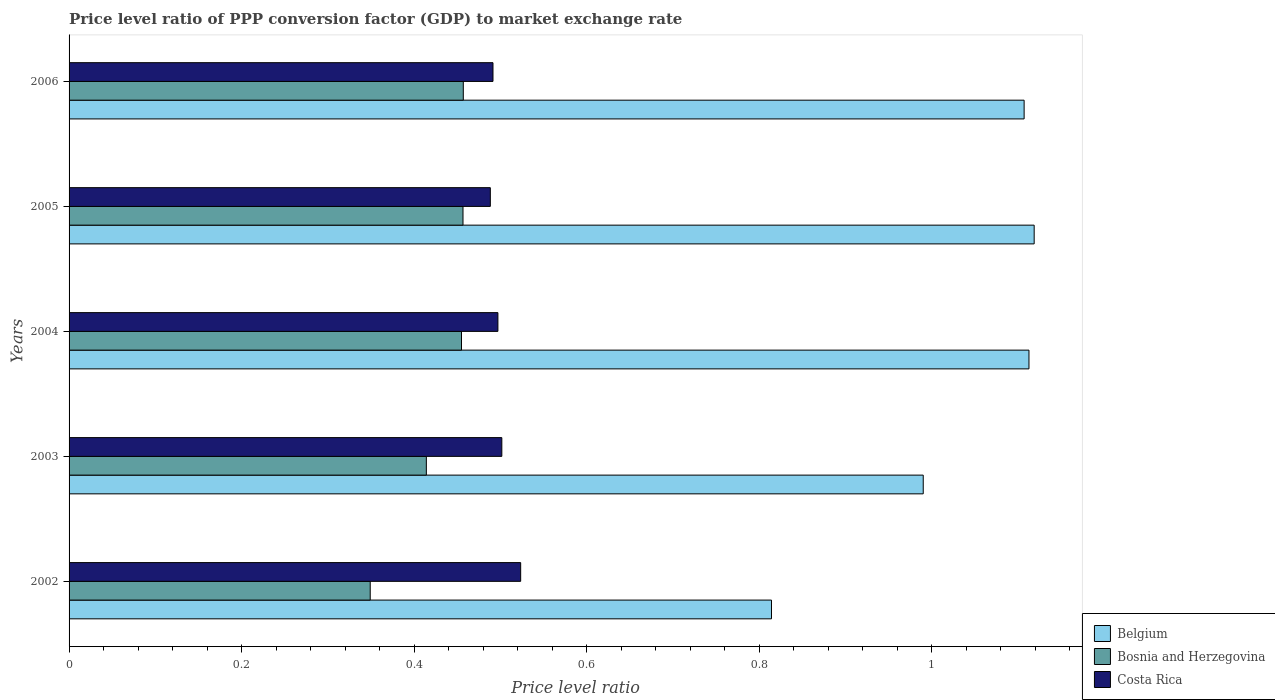How many different coloured bars are there?
Give a very brief answer. 3. Are the number of bars per tick equal to the number of legend labels?
Offer a terse response. Yes. How many bars are there on the 3rd tick from the bottom?
Offer a very short reply. 3. In how many cases, is the number of bars for a given year not equal to the number of legend labels?
Make the answer very short. 0. What is the price level ratio in Costa Rica in 2005?
Give a very brief answer. 0.49. Across all years, what is the maximum price level ratio in Costa Rica?
Keep it short and to the point. 0.52. Across all years, what is the minimum price level ratio in Bosnia and Herzegovina?
Offer a very short reply. 0.35. In which year was the price level ratio in Costa Rica maximum?
Make the answer very short. 2002. What is the total price level ratio in Costa Rica in the graph?
Offer a terse response. 2.5. What is the difference between the price level ratio in Belgium in 2002 and that in 2003?
Your answer should be very brief. -0.18. What is the difference between the price level ratio in Costa Rica in 2006 and the price level ratio in Belgium in 2005?
Your answer should be very brief. -0.63. What is the average price level ratio in Costa Rica per year?
Offer a terse response. 0.5. In the year 2003, what is the difference between the price level ratio in Belgium and price level ratio in Costa Rica?
Offer a terse response. 0.49. In how many years, is the price level ratio in Bosnia and Herzegovina greater than 0.12 ?
Give a very brief answer. 5. What is the ratio of the price level ratio in Bosnia and Herzegovina in 2004 to that in 2006?
Offer a terse response. 1. What is the difference between the highest and the second highest price level ratio in Bosnia and Herzegovina?
Offer a very short reply. 0. What is the difference between the highest and the lowest price level ratio in Bosnia and Herzegovina?
Keep it short and to the point. 0.11. In how many years, is the price level ratio in Bosnia and Herzegovina greater than the average price level ratio in Bosnia and Herzegovina taken over all years?
Make the answer very short. 3. Is the sum of the price level ratio in Bosnia and Herzegovina in 2002 and 2006 greater than the maximum price level ratio in Costa Rica across all years?
Offer a very short reply. Yes. What does the 3rd bar from the bottom in 2002 represents?
Your answer should be very brief. Costa Rica. Is it the case that in every year, the sum of the price level ratio in Costa Rica and price level ratio in Belgium is greater than the price level ratio in Bosnia and Herzegovina?
Provide a short and direct response. Yes. How many bars are there?
Your answer should be very brief. 15. Are all the bars in the graph horizontal?
Make the answer very short. Yes. How many years are there in the graph?
Ensure brevity in your answer.  5. What is the difference between two consecutive major ticks on the X-axis?
Offer a very short reply. 0.2. Are the values on the major ticks of X-axis written in scientific E-notation?
Provide a succinct answer. No. Does the graph contain any zero values?
Offer a very short reply. No. What is the title of the graph?
Provide a succinct answer. Price level ratio of PPP conversion factor (GDP) to market exchange rate. Does "Somalia" appear as one of the legend labels in the graph?
Provide a succinct answer. No. What is the label or title of the X-axis?
Your answer should be very brief. Price level ratio. What is the label or title of the Y-axis?
Give a very brief answer. Years. What is the Price level ratio in Belgium in 2002?
Your answer should be very brief. 0.81. What is the Price level ratio of Bosnia and Herzegovina in 2002?
Keep it short and to the point. 0.35. What is the Price level ratio in Costa Rica in 2002?
Keep it short and to the point. 0.52. What is the Price level ratio of Belgium in 2003?
Give a very brief answer. 0.99. What is the Price level ratio in Bosnia and Herzegovina in 2003?
Keep it short and to the point. 0.41. What is the Price level ratio in Costa Rica in 2003?
Offer a terse response. 0.5. What is the Price level ratio of Belgium in 2004?
Ensure brevity in your answer.  1.11. What is the Price level ratio of Bosnia and Herzegovina in 2004?
Your answer should be very brief. 0.45. What is the Price level ratio in Costa Rica in 2004?
Provide a succinct answer. 0.5. What is the Price level ratio of Belgium in 2005?
Make the answer very short. 1.12. What is the Price level ratio of Bosnia and Herzegovina in 2005?
Provide a short and direct response. 0.46. What is the Price level ratio in Costa Rica in 2005?
Ensure brevity in your answer.  0.49. What is the Price level ratio in Belgium in 2006?
Offer a terse response. 1.11. What is the Price level ratio in Bosnia and Herzegovina in 2006?
Give a very brief answer. 0.46. What is the Price level ratio in Costa Rica in 2006?
Keep it short and to the point. 0.49. Across all years, what is the maximum Price level ratio in Belgium?
Provide a succinct answer. 1.12. Across all years, what is the maximum Price level ratio of Bosnia and Herzegovina?
Provide a short and direct response. 0.46. Across all years, what is the maximum Price level ratio of Costa Rica?
Your answer should be compact. 0.52. Across all years, what is the minimum Price level ratio in Belgium?
Make the answer very short. 0.81. Across all years, what is the minimum Price level ratio of Bosnia and Herzegovina?
Provide a succinct answer. 0.35. Across all years, what is the minimum Price level ratio of Costa Rica?
Offer a terse response. 0.49. What is the total Price level ratio of Belgium in the graph?
Your response must be concise. 5.14. What is the total Price level ratio in Bosnia and Herzegovina in the graph?
Offer a very short reply. 2.13. What is the total Price level ratio in Costa Rica in the graph?
Provide a short and direct response. 2.5. What is the difference between the Price level ratio in Belgium in 2002 and that in 2003?
Provide a succinct answer. -0.18. What is the difference between the Price level ratio in Bosnia and Herzegovina in 2002 and that in 2003?
Keep it short and to the point. -0.07. What is the difference between the Price level ratio in Costa Rica in 2002 and that in 2003?
Your answer should be very brief. 0.02. What is the difference between the Price level ratio in Belgium in 2002 and that in 2004?
Provide a succinct answer. -0.3. What is the difference between the Price level ratio in Bosnia and Herzegovina in 2002 and that in 2004?
Give a very brief answer. -0.11. What is the difference between the Price level ratio in Costa Rica in 2002 and that in 2004?
Your answer should be very brief. 0.03. What is the difference between the Price level ratio of Belgium in 2002 and that in 2005?
Provide a succinct answer. -0.3. What is the difference between the Price level ratio in Bosnia and Herzegovina in 2002 and that in 2005?
Provide a succinct answer. -0.11. What is the difference between the Price level ratio in Costa Rica in 2002 and that in 2005?
Give a very brief answer. 0.04. What is the difference between the Price level ratio of Belgium in 2002 and that in 2006?
Keep it short and to the point. -0.29. What is the difference between the Price level ratio of Bosnia and Herzegovina in 2002 and that in 2006?
Provide a succinct answer. -0.11. What is the difference between the Price level ratio of Costa Rica in 2002 and that in 2006?
Provide a succinct answer. 0.03. What is the difference between the Price level ratio of Belgium in 2003 and that in 2004?
Ensure brevity in your answer.  -0.12. What is the difference between the Price level ratio in Bosnia and Herzegovina in 2003 and that in 2004?
Ensure brevity in your answer.  -0.04. What is the difference between the Price level ratio of Costa Rica in 2003 and that in 2004?
Offer a very short reply. 0. What is the difference between the Price level ratio in Belgium in 2003 and that in 2005?
Your answer should be compact. -0.13. What is the difference between the Price level ratio of Bosnia and Herzegovina in 2003 and that in 2005?
Your response must be concise. -0.04. What is the difference between the Price level ratio in Costa Rica in 2003 and that in 2005?
Make the answer very short. 0.01. What is the difference between the Price level ratio in Belgium in 2003 and that in 2006?
Give a very brief answer. -0.12. What is the difference between the Price level ratio of Bosnia and Herzegovina in 2003 and that in 2006?
Make the answer very short. -0.04. What is the difference between the Price level ratio of Costa Rica in 2003 and that in 2006?
Your answer should be compact. 0.01. What is the difference between the Price level ratio of Belgium in 2004 and that in 2005?
Make the answer very short. -0.01. What is the difference between the Price level ratio of Bosnia and Herzegovina in 2004 and that in 2005?
Keep it short and to the point. -0. What is the difference between the Price level ratio in Costa Rica in 2004 and that in 2005?
Your response must be concise. 0.01. What is the difference between the Price level ratio of Belgium in 2004 and that in 2006?
Ensure brevity in your answer.  0.01. What is the difference between the Price level ratio in Bosnia and Herzegovina in 2004 and that in 2006?
Offer a very short reply. -0. What is the difference between the Price level ratio in Costa Rica in 2004 and that in 2006?
Ensure brevity in your answer.  0.01. What is the difference between the Price level ratio in Belgium in 2005 and that in 2006?
Your answer should be compact. 0.01. What is the difference between the Price level ratio in Bosnia and Herzegovina in 2005 and that in 2006?
Offer a very short reply. -0. What is the difference between the Price level ratio of Costa Rica in 2005 and that in 2006?
Your response must be concise. -0. What is the difference between the Price level ratio of Belgium in 2002 and the Price level ratio of Bosnia and Herzegovina in 2003?
Keep it short and to the point. 0.4. What is the difference between the Price level ratio in Belgium in 2002 and the Price level ratio in Costa Rica in 2003?
Provide a succinct answer. 0.31. What is the difference between the Price level ratio of Bosnia and Herzegovina in 2002 and the Price level ratio of Costa Rica in 2003?
Provide a short and direct response. -0.15. What is the difference between the Price level ratio of Belgium in 2002 and the Price level ratio of Bosnia and Herzegovina in 2004?
Provide a short and direct response. 0.36. What is the difference between the Price level ratio in Belgium in 2002 and the Price level ratio in Costa Rica in 2004?
Provide a short and direct response. 0.32. What is the difference between the Price level ratio of Bosnia and Herzegovina in 2002 and the Price level ratio of Costa Rica in 2004?
Keep it short and to the point. -0.15. What is the difference between the Price level ratio in Belgium in 2002 and the Price level ratio in Bosnia and Herzegovina in 2005?
Your response must be concise. 0.36. What is the difference between the Price level ratio in Belgium in 2002 and the Price level ratio in Costa Rica in 2005?
Give a very brief answer. 0.33. What is the difference between the Price level ratio in Bosnia and Herzegovina in 2002 and the Price level ratio in Costa Rica in 2005?
Provide a short and direct response. -0.14. What is the difference between the Price level ratio in Belgium in 2002 and the Price level ratio in Bosnia and Herzegovina in 2006?
Ensure brevity in your answer.  0.36. What is the difference between the Price level ratio in Belgium in 2002 and the Price level ratio in Costa Rica in 2006?
Offer a very short reply. 0.32. What is the difference between the Price level ratio in Bosnia and Herzegovina in 2002 and the Price level ratio in Costa Rica in 2006?
Give a very brief answer. -0.14. What is the difference between the Price level ratio in Belgium in 2003 and the Price level ratio in Bosnia and Herzegovina in 2004?
Your answer should be compact. 0.54. What is the difference between the Price level ratio in Belgium in 2003 and the Price level ratio in Costa Rica in 2004?
Your answer should be compact. 0.49. What is the difference between the Price level ratio in Bosnia and Herzegovina in 2003 and the Price level ratio in Costa Rica in 2004?
Offer a terse response. -0.08. What is the difference between the Price level ratio of Belgium in 2003 and the Price level ratio of Bosnia and Herzegovina in 2005?
Give a very brief answer. 0.53. What is the difference between the Price level ratio in Belgium in 2003 and the Price level ratio in Costa Rica in 2005?
Your response must be concise. 0.5. What is the difference between the Price level ratio in Bosnia and Herzegovina in 2003 and the Price level ratio in Costa Rica in 2005?
Give a very brief answer. -0.07. What is the difference between the Price level ratio in Belgium in 2003 and the Price level ratio in Bosnia and Herzegovina in 2006?
Offer a very short reply. 0.53. What is the difference between the Price level ratio of Belgium in 2003 and the Price level ratio of Costa Rica in 2006?
Offer a terse response. 0.5. What is the difference between the Price level ratio of Bosnia and Herzegovina in 2003 and the Price level ratio of Costa Rica in 2006?
Your answer should be compact. -0.08. What is the difference between the Price level ratio of Belgium in 2004 and the Price level ratio of Bosnia and Herzegovina in 2005?
Keep it short and to the point. 0.66. What is the difference between the Price level ratio of Belgium in 2004 and the Price level ratio of Costa Rica in 2005?
Offer a terse response. 0.62. What is the difference between the Price level ratio of Bosnia and Herzegovina in 2004 and the Price level ratio of Costa Rica in 2005?
Provide a short and direct response. -0.03. What is the difference between the Price level ratio in Belgium in 2004 and the Price level ratio in Bosnia and Herzegovina in 2006?
Provide a short and direct response. 0.66. What is the difference between the Price level ratio in Belgium in 2004 and the Price level ratio in Costa Rica in 2006?
Offer a very short reply. 0.62. What is the difference between the Price level ratio in Bosnia and Herzegovina in 2004 and the Price level ratio in Costa Rica in 2006?
Your response must be concise. -0.04. What is the difference between the Price level ratio of Belgium in 2005 and the Price level ratio of Bosnia and Herzegovina in 2006?
Provide a short and direct response. 0.66. What is the difference between the Price level ratio of Belgium in 2005 and the Price level ratio of Costa Rica in 2006?
Make the answer very short. 0.63. What is the difference between the Price level ratio in Bosnia and Herzegovina in 2005 and the Price level ratio in Costa Rica in 2006?
Provide a short and direct response. -0.03. What is the average Price level ratio of Belgium per year?
Offer a very short reply. 1.03. What is the average Price level ratio in Bosnia and Herzegovina per year?
Make the answer very short. 0.43. What is the average Price level ratio in Costa Rica per year?
Offer a very short reply. 0.5. In the year 2002, what is the difference between the Price level ratio in Belgium and Price level ratio in Bosnia and Herzegovina?
Give a very brief answer. 0.47. In the year 2002, what is the difference between the Price level ratio of Belgium and Price level ratio of Costa Rica?
Provide a short and direct response. 0.29. In the year 2002, what is the difference between the Price level ratio in Bosnia and Herzegovina and Price level ratio in Costa Rica?
Give a very brief answer. -0.17. In the year 2003, what is the difference between the Price level ratio of Belgium and Price level ratio of Bosnia and Herzegovina?
Offer a very short reply. 0.58. In the year 2003, what is the difference between the Price level ratio in Belgium and Price level ratio in Costa Rica?
Your answer should be compact. 0.49. In the year 2003, what is the difference between the Price level ratio of Bosnia and Herzegovina and Price level ratio of Costa Rica?
Provide a short and direct response. -0.09. In the year 2004, what is the difference between the Price level ratio in Belgium and Price level ratio in Bosnia and Herzegovina?
Make the answer very short. 0.66. In the year 2004, what is the difference between the Price level ratio in Belgium and Price level ratio in Costa Rica?
Offer a terse response. 0.62. In the year 2004, what is the difference between the Price level ratio in Bosnia and Herzegovina and Price level ratio in Costa Rica?
Offer a very short reply. -0.04. In the year 2005, what is the difference between the Price level ratio in Belgium and Price level ratio in Bosnia and Herzegovina?
Make the answer very short. 0.66. In the year 2005, what is the difference between the Price level ratio of Belgium and Price level ratio of Costa Rica?
Your response must be concise. 0.63. In the year 2005, what is the difference between the Price level ratio of Bosnia and Herzegovina and Price level ratio of Costa Rica?
Offer a very short reply. -0.03. In the year 2006, what is the difference between the Price level ratio of Belgium and Price level ratio of Bosnia and Herzegovina?
Provide a succinct answer. 0.65. In the year 2006, what is the difference between the Price level ratio in Belgium and Price level ratio in Costa Rica?
Make the answer very short. 0.62. In the year 2006, what is the difference between the Price level ratio of Bosnia and Herzegovina and Price level ratio of Costa Rica?
Provide a succinct answer. -0.03. What is the ratio of the Price level ratio of Belgium in 2002 to that in 2003?
Ensure brevity in your answer.  0.82. What is the ratio of the Price level ratio of Bosnia and Herzegovina in 2002 to that in 2003?
Make the answer very short. 0.84. What is the ratio of the Price level ratio in Costa Rica in 2002 to that in 2003?
Give a very brief answer. 1.04. What is the ratio of the Price level ratio in Belgium in 2002 to that in 2004?
Provide a succinct answer. 0.73. What is the ratio of the Price level ratio in Bosnia and Herzegovina in 2002 to that in 2004?
Your answer should be very brief. 0.77. What is the ratio of the Price level ratio in Costa Rica in 2002 to that in 2004?
Make the answer very short. 1.05. What is the ratio of the Price level ratio in Belgium in 2002 to that in 2005?
Keep it short and to the point. 0.73. What is the ratio of the Price level ratio of Bosnia and Herzegovina in 2002 to that in 2005?
Provide a succinct answer. 0.76. What is the ratio of the Price level ratio in Costa Rica in 2002 to that in 2005?
Make the answer very short. 1.07. What is the ratio of the Price level ratio in Belgium in 2002 to that in 2006?
Your response must be concise. 0.74. What is the ratio of the Price level ratio of Bosnia and Herzegovina in 2002 to that in 2006?
Your response must be concise. 0.76. What is the ratio of the Price level ratio of Costa Rica in 2002 to that in 2006?
Keep it short and to the point. 1.07. What is the ratio of the Price level ratio in Belgium in 2003 to that in 2004?
Your response must be concise. 0.89. What is the ratio of the Price level ratio in Bosnia and Herzegovina in 2003 to that in 2004?
Your response must be concise. 0.91. What is the ratio of the Price level ratio of Costa Rica in 2003 to that in 2004?
Make the answer very short. 1.01. What is the ratio of the Price level ratio of Belgium in 2003 to that in 2005?
Keep it short and to the point. 0.89. What is the ratio of the Price level ratio of Bosnia and Herzegovina in 2003 to that in 2005?
Your response must be concise. 0.91. What is the ratio of the Price level ratio in Costa Rica in 2003 to that in 2005?
Provide a succinct answer. 1.03. What is the ratio of the Price level ratio in Belgium in 2003 to that in 2006?
Your answer should be very brief. 0.89. What is the ratio of the Price level ratio of Bosnia and Herzegovina in 2003 to that in 2006?
Ensure brevity in your answer.  0.91. What is the ratio of the Price level ratio of Costa Rica in 2003 to that in 2006?
Make the answer very short. 1.02. What is the ratio of the Price level ratio in Belgium in 2004 to that in 2005?
Provide a succinct answer. 0.99. What is the ratio of the Price level ratio of Costa Rica in 2004 to that in 2005?
Offer a terse response. 1.02. What is the ratio of the Price level ratio in Bosnia and Herzegovina in 2004 to that in 2006?
Offer a terse response. 1. What is the ratio of the Price level ratio of Costa Rica in 2004 to that in 2006?
Your answer should be very brief. 1.01. What is the ratio of the Price level ratio of Belgium in 2005 to that in 2006?
Ensure brevity in your answer.  1.01. What is the ratio of the Price level ratio of Costa Rica in 2005 to that in 2006?
Provide a short and direct response. 0.99. What is the difference between the highest and the second highest Price level ratio in Belgium?
Provide a short and direct response. 0.01. What is the difference between the highest and the second highest Price level ratio of Costa Rica?
Offer a terse response. 0.02. What is the difference between the highest and the lowest Price level ratio in Belgium?
Offer a terse response. 0.3. What is the difference between the highest and the lowest Price level ratio of Bosnia and Herzegovina?
Ensure brevity in your answer.  0.11. What is the difference between the highest and the lowest Price level ratio of Costa Rica?
Your answer should be compact. 0.04. 